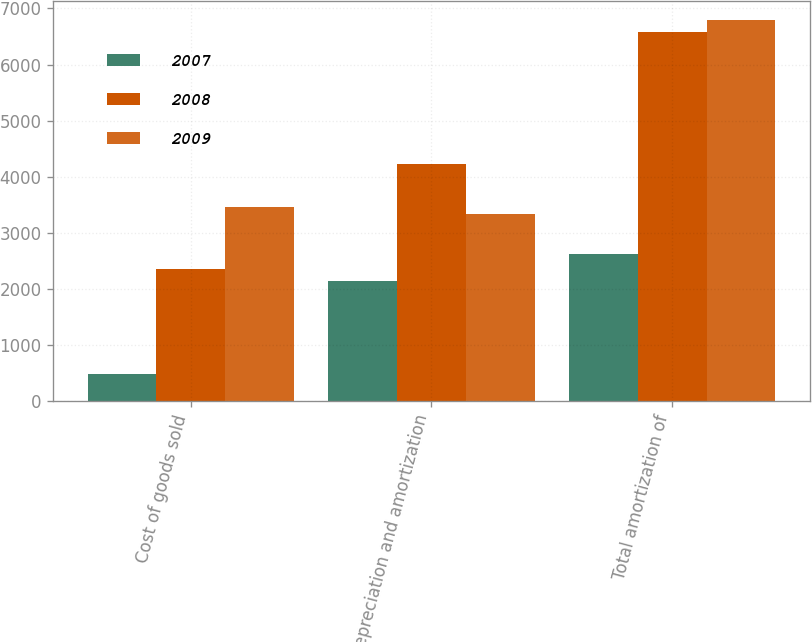Convert chart. <chart><loc_0><loc_0><loc_500><loc_500><stacked_bar_chart><ecel><fcel>Cost of goods sold<fcel>Depreciation and amortization<fcel>Total amortization of<nl><fcel>2007<fcel>478<fcel>2136<fcel>2614<nl><fcel>2008<fcel>2350<fcel>4229<fcel>6579<nl><fcel>2009<fcel>3462<fcel>3334<fcel>6796<nl></chart> 